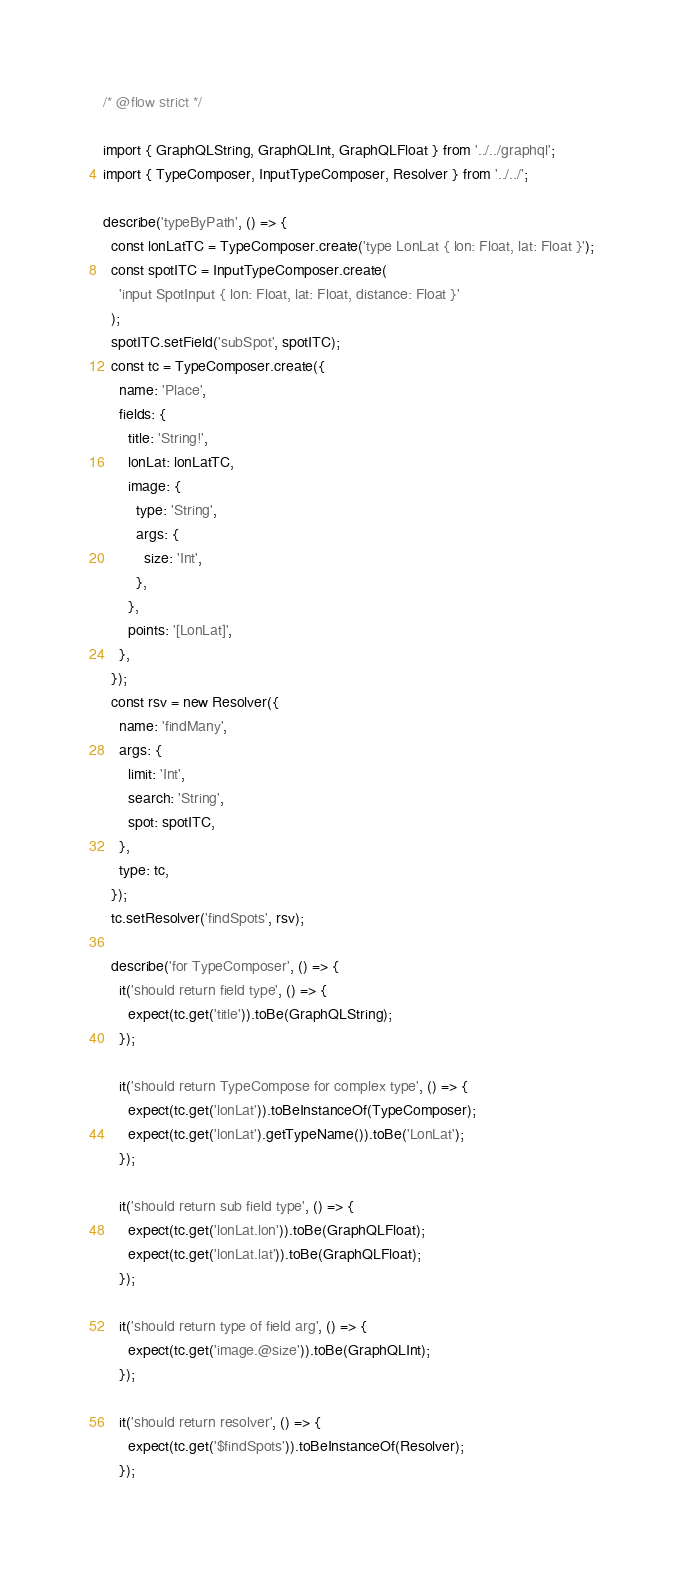<code> <loc_0><loc_0><loc_500><loc_500><_JavaScript_>/* @flow strict */

import { GraphQLString, GraphQLInt, GraphQLFloat } from '../../graphql';
import { TypeComposer, InputTypeComposer, Resolver } from '../../';

describe('typeByPath', () => {
  const lonLatTC = TypeComposer.create('type LonLat { lon: Float, lat: Float }');
  const spotITC = InputTypeComposer.create(
    'input SpotInput { lon: Float, lat: Float, distance: Float }'
  );
  spotITC.setField('subSpot', spotITC);
  const tc = TypeComposer.create({
    name: 'Place',
    fields: {
      title: 'String!',
      lonLat: lonLatTC,
      image: {
        type: 'String',
        args: {
          size: 'Int',
        },
      },
      points: '[LonLat]',
    },
  });
  const rsv = new Resolver({
    name: 'findMany',
    args: {
      limit: 'Int',
      search: 'String',
      spot: spotITC,
    },
    type: tc,
  });
  tc.setResolver('findSpots', rsv);

  describe('for TypeComposer', () => {
    it('should return field type', () => {
      expect(tc.get('title')).toBe(GraphQLString);
    });

    it('should return TypeCompose for complex type', () => {
      expect(tc.get('lonLat')).toBeInstanceOf(TypeComposer);
      expect(tc.get('lonLat').getTypeName()).toBe('LonLat');
    });

    it('should return sub field type', () => {
      expect(tc.get('lonLat.lon')).toBe(GraphQLFloat);
      expect(tc.get('lonLat.lat')).toBe(GraphQLFloat);
    });

    it('should return type of field arg', () => {
      expect(tc.get('image.@size')).toBe(GraphQLInt);
    });

    it('should return resolver', () => {
      expect(tc.get('$findSpots')).toBeInstanceOf(Resolver);
    });
</code> 